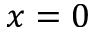<formula> <loc_0><loc_0><loc_500><loc_500>x = 0</formula> 